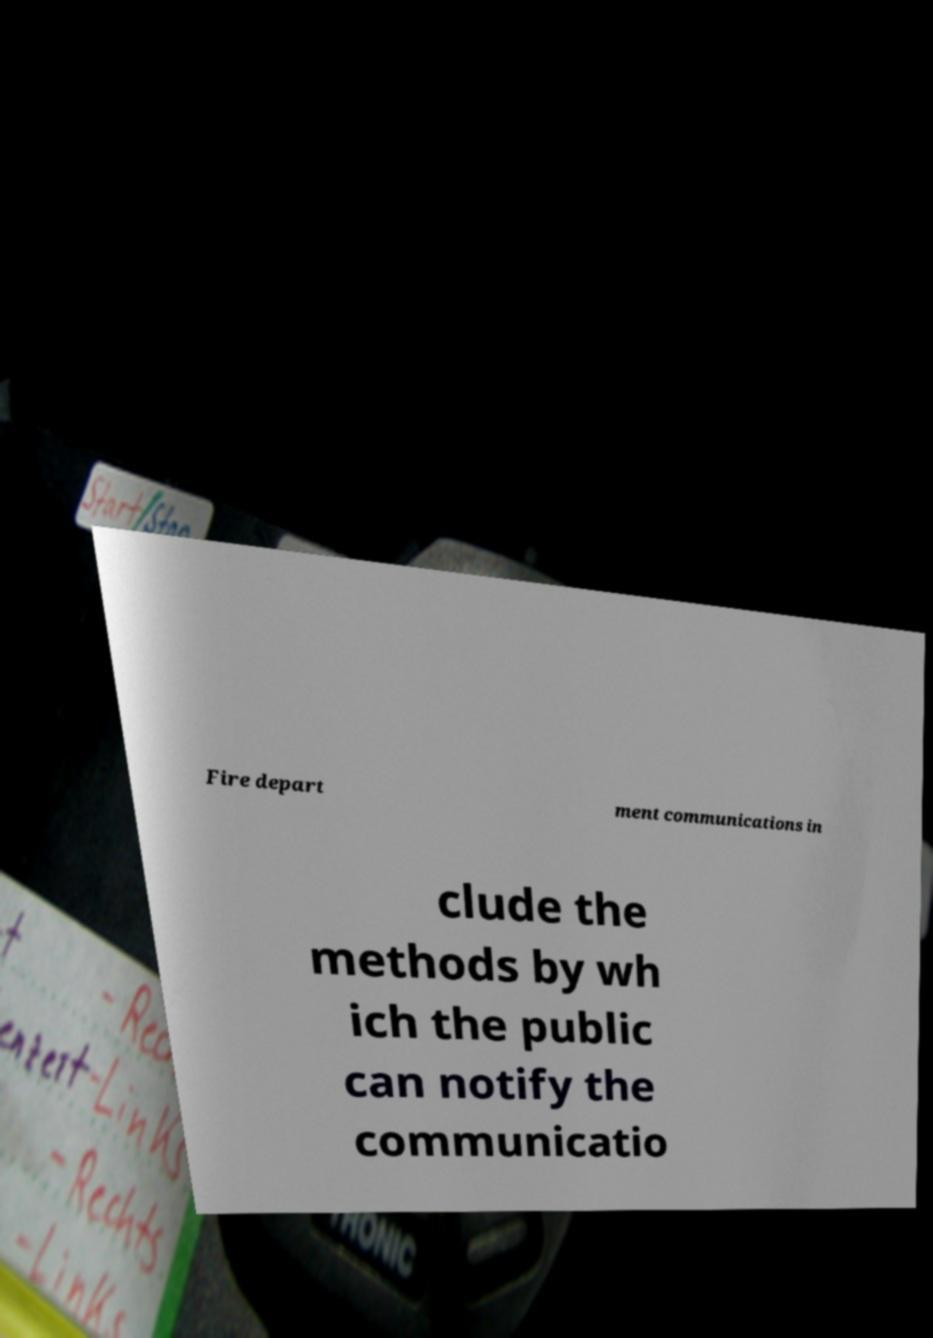There's text embedded in this image that I need extracted. Can you transcribe it verbatim? Fire depart ment communications in clude the methods by wh ich the public can notify the communicatio 